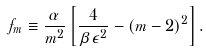Convert formula to latex. <formula><loc_0><loc_0><loc_500><loc_500>f _ { m } \equiv \frac { \alpha } { m ^ { 2 } } \left [ \frac { 4 } { \beta \epsilon ^ { 2 } } - ( m - 2 ) ^ { 2 } \right ] .</formula> 